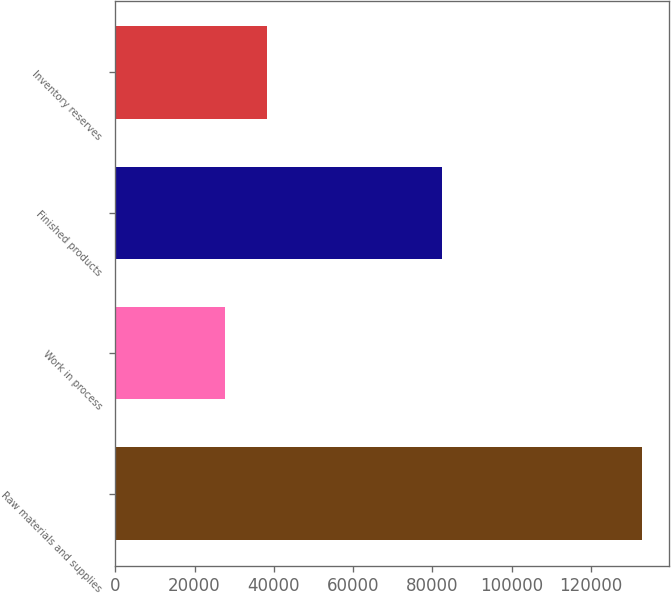<chart> <loc_0><loc_0><loc_500><loc_500><bar_chart><fcel>Raw materials and supplies<fcel>Work in process<fcel>Finished products<fcel>Inventory reserves<nl><fcel>132949<fcel>27649<fcel>82445<fcel>38179<nl></chart> 